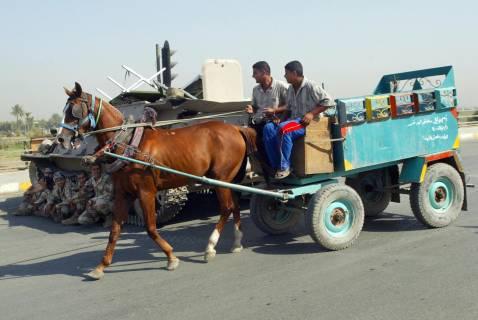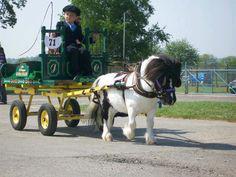The first image is the image on the left, the second image is the image on the right. Considering the images on both sides, is "There are no less than three animals pulling something on wheels." valid? Answer yes or no. No. The first image is the image on the left, the second image is the image on the right. For the images shown, is this caption "the right side pics has a four wheel wagon moving to the right" true? Answer yes or no. Yes. 